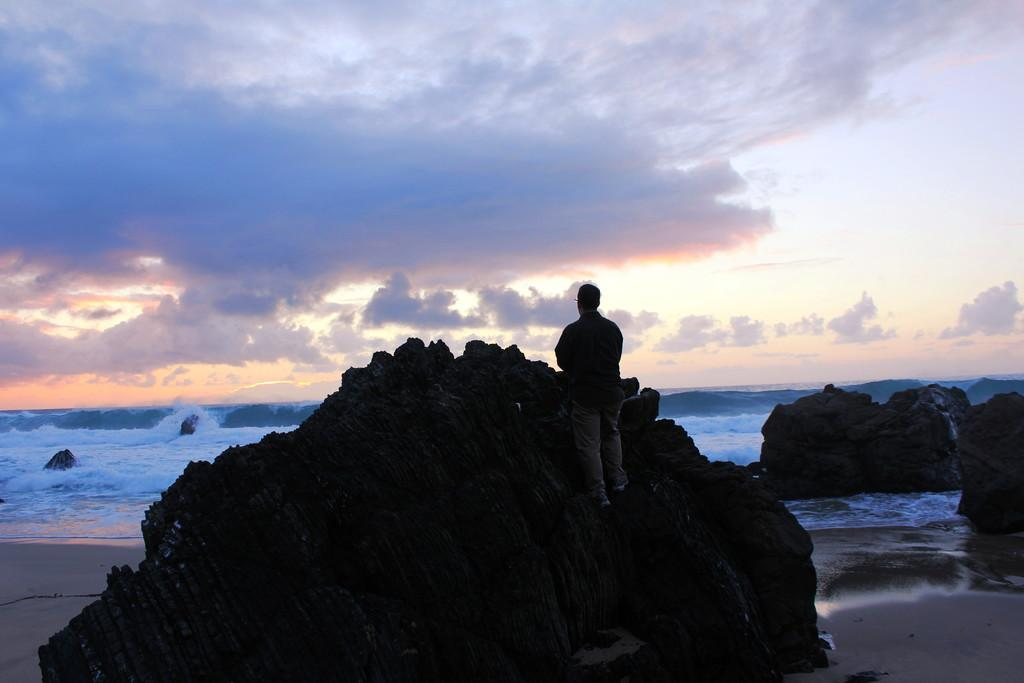What type of natural formation can be seen in the image? There are rocks in the image. What body of water is visible in the image? There is sea visible in the image. Can you describe the position of the man in the image? There is a man standing on one of the rocks in the front. What type of powder is being used by the man standing on the rock in the image? There is no powder visible in the image, and the man is not using any powder. Can you recite the verse that is being spoken by the man standing on the rock in the image? There is no verse being spoken by the man in the image, and we cannot recite something that is not present. 